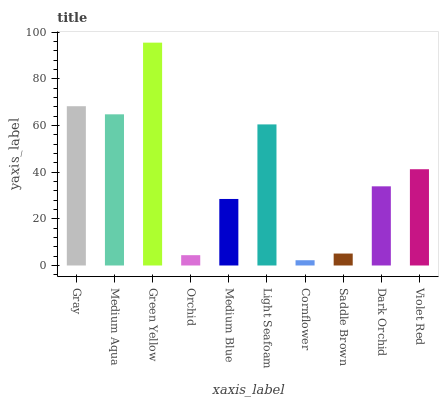Is Cornflower the minimum?
Answer yes or no. Yes. Is Green Yellow the maximum?
Answer yes or no. Yes. Is Medium Aqua the minimum?
Answer yes or no. No. Is Medium Aqua the maximum?
Answer yes or no. No. Is Gray greater than Medium Aqua?
Answer yes or no. Yes. Is Medium Aqua less than Gray?
Answer yes or no. Yes. Is Medium Aqua greater than Gray?
Answer yes or no. No. Is Gray less than Medium Aqua?
Answer yes or no. No. Is Violet Red the high median?
Answer yes or no. Yes. Is Dark Orchid the low median?
Answer yes or no. Yes. Is Orchid the high median?
Answer yes or no. No. Is Medium Aqua the low median?
Answer yes or no. No. 